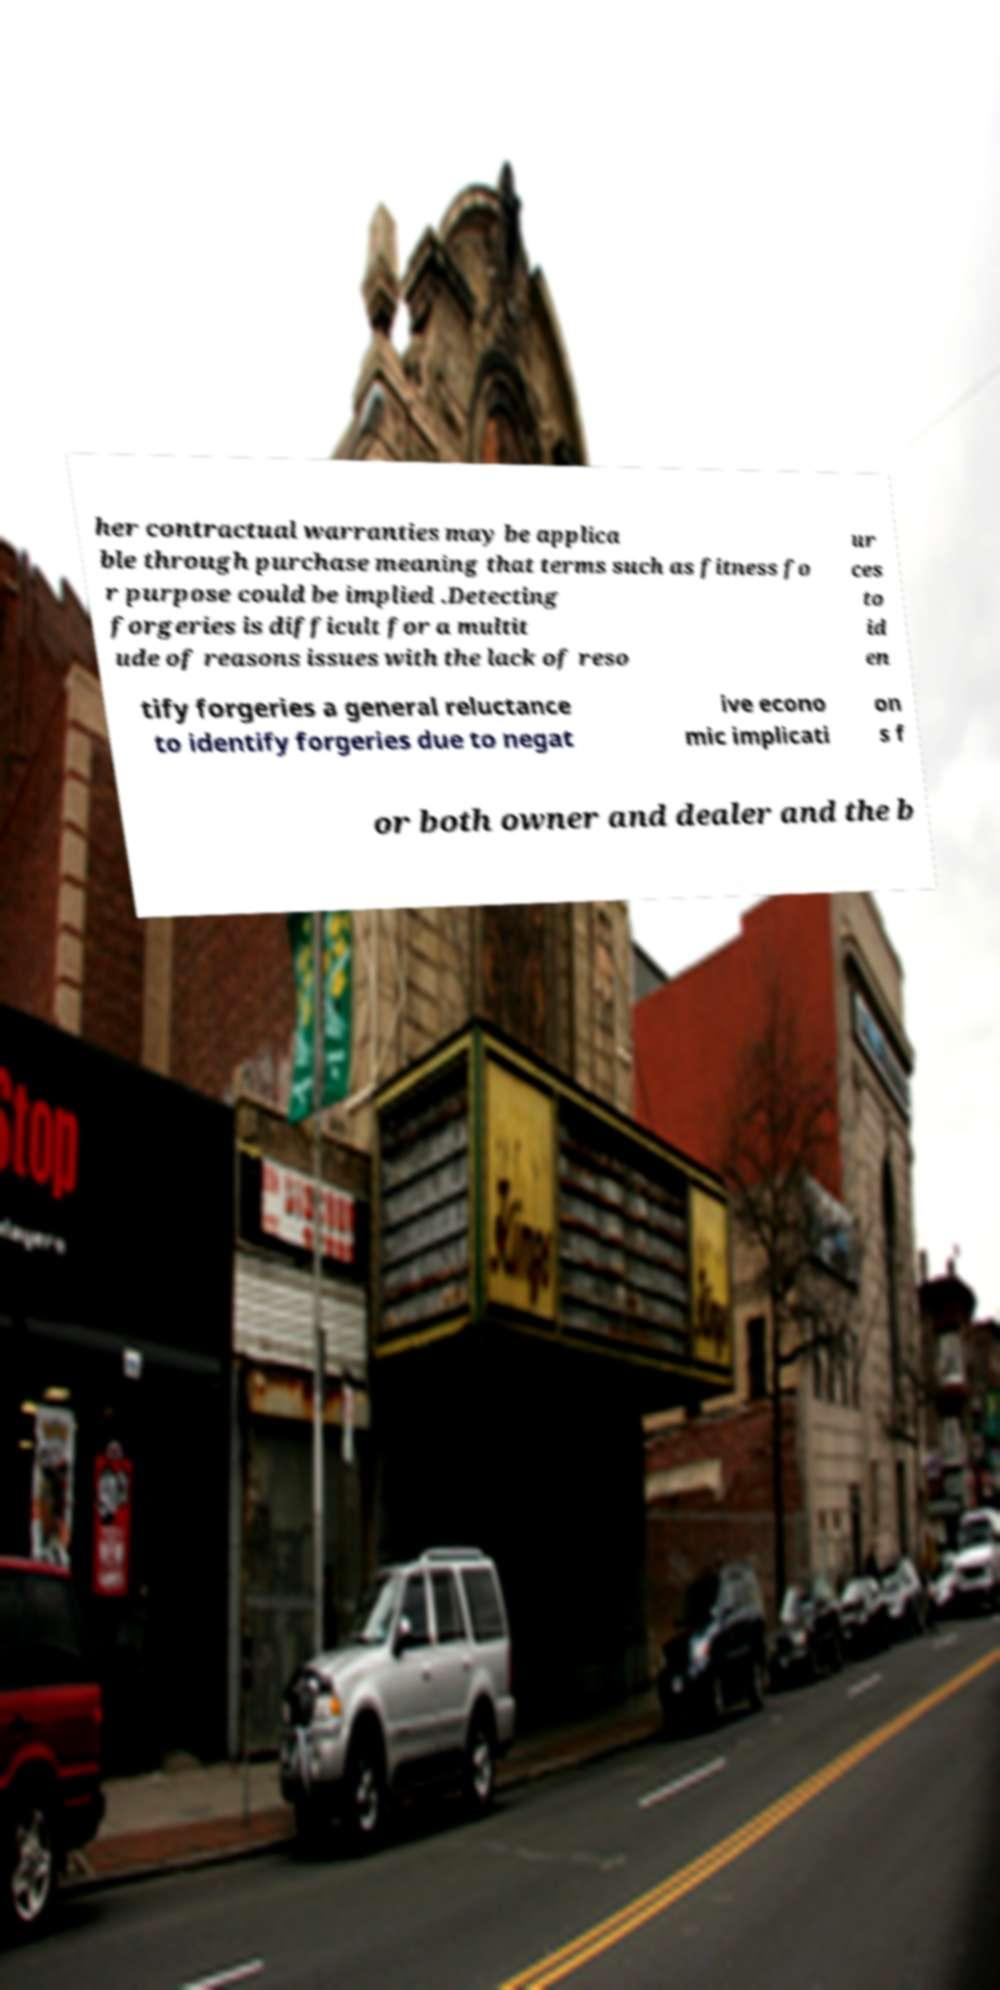Please read and relay the text visible in this image. What does it say? her contractual warranties may be applica ble through purchase meaning that terms such as fitness fo r purpose could be implied .Detecting forgeries is difficult for a multit ude of reasons issues with the lack of reso ur ces to id en tify forgeries a general reluctance to identify forgeries due to negat ive econo mic implicati on s f or both owner and dealer and the b 